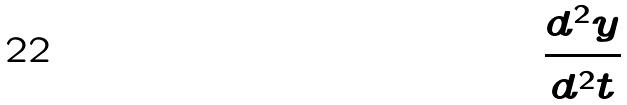<formula> <loc_0><loc_0><loc_500><loc_500>\frac { d ^ { 2 } y } { d ^ { 2 } t }</formula> 